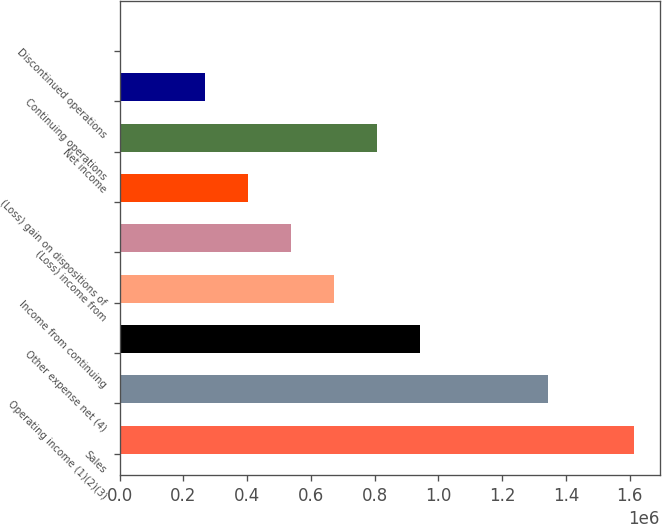<chart> <loc_0><loc_0><loc_500><loc_500><bar_chart><fcel>Sales<fcel>Operating income (1)(2)(3)<fcel>Other expense net (4)<fcel>Income from continuing<fcel>(Loss) income from<fcel>(Loss) gain on dispositions of<fcel>Net income<fcel>Continuing operations<fcel>Discontinued operations<nl><fcel>1.61345e+06<fcel>1.34454e+06<fcel>941178<fcel>672270<fcel>537816<fcel>403362<fcel>806724<fcel>268908<fcel>0.02<nl></chart> 